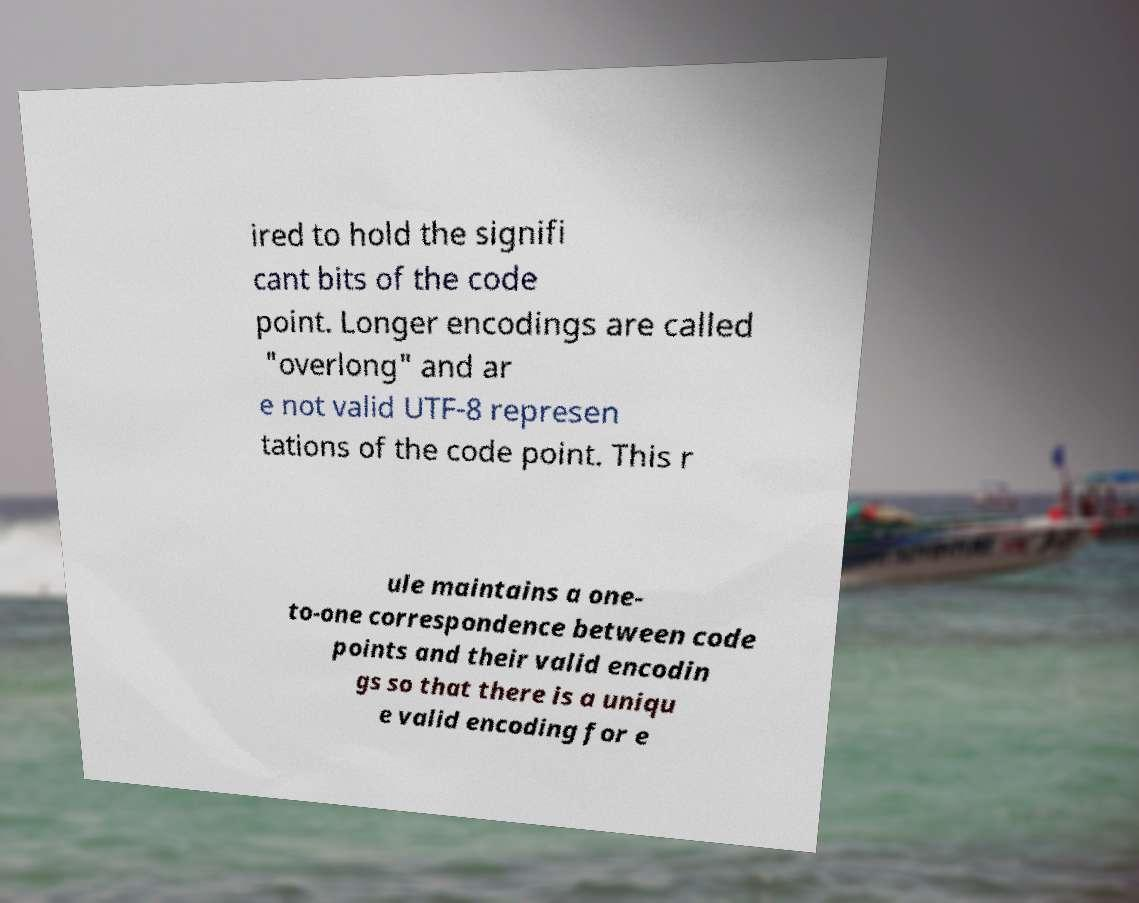I need the written content from this picture converted into text. Can you do that? ired to hold the signifi cant bits of the code point. Longer encodings are called "overlong" and ar e not valid UTF-8 represen tations of the code point. This r ule maintains a one- to-one correspondence between code points and their valid encodin gs so that there is a uniqu e valid encoding for e 